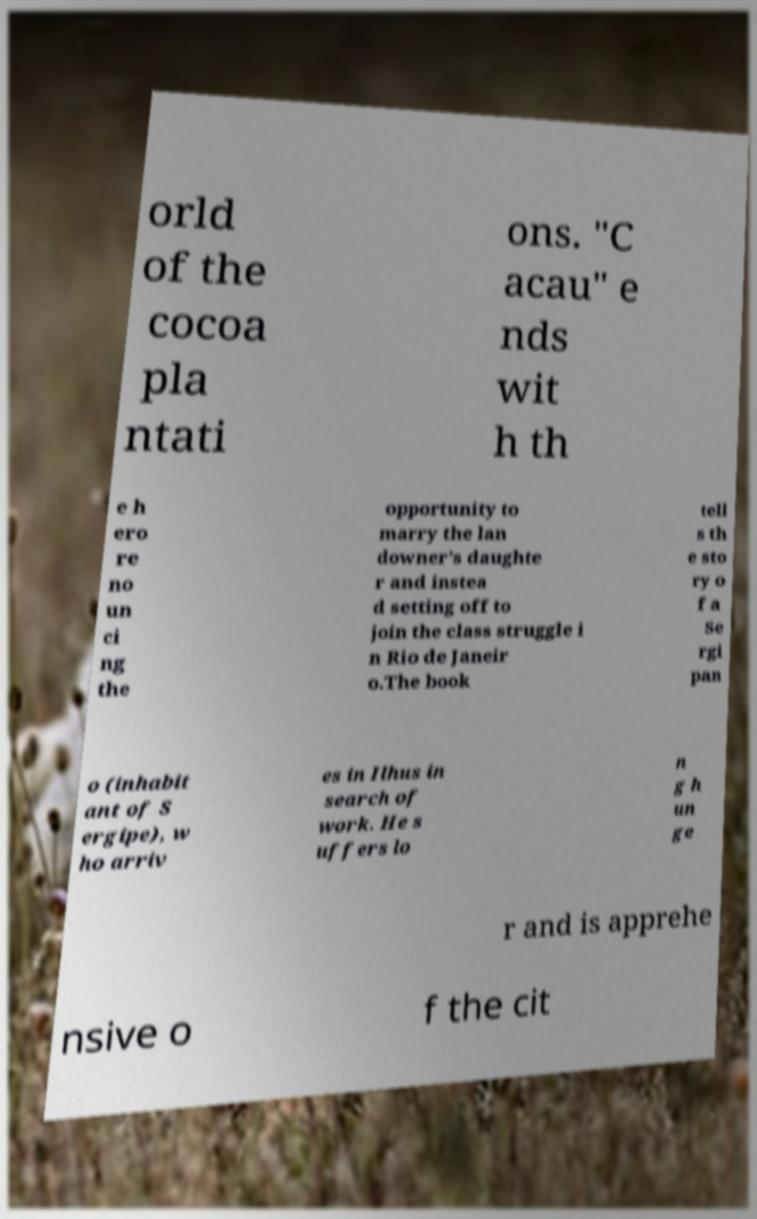What messages or text are displayed in this image? I need them in a readable, typed format. orld of the cocoa pla ntati ons. "C acau" e nds wit h th e h ero re no un ci ng the opportunity to marry the lan downer’s daughte r and instea d setting off to join the class struggle i n Rio de Janeir o.The book tell s th e sto ry o f a Se rgi pan o (inhabit ant of S ergipe), w ho arriv es in Ilhus in search of work. He s uffers lo n g h un ge r and is apprehe nsive o f the cit 